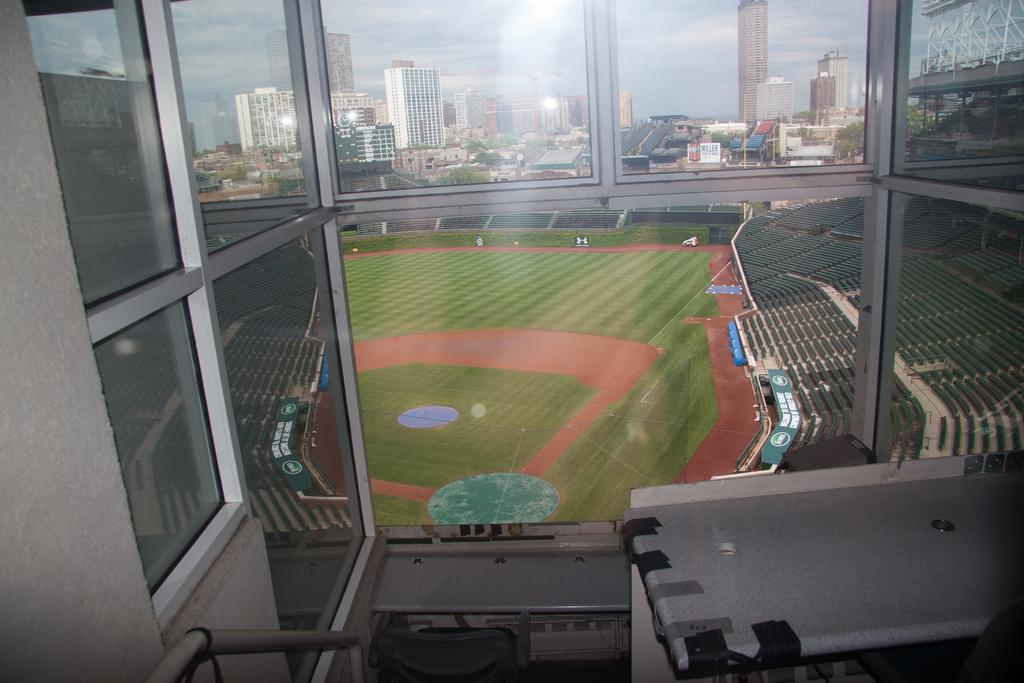What type of surface can be seen in the image? There is ground visible in the image. What type of furniture is present in the image? There are chairs in the image. What type of structures are visible in the image? There are buildings in the image. What is visible in the sky in the image? The sky is visible in the image, and clouds are present. What type of juice is being served at the protest in the image? There is no protest or juice present in the image. How many eggs are visible in the image? There are no eggs visible in the image. 